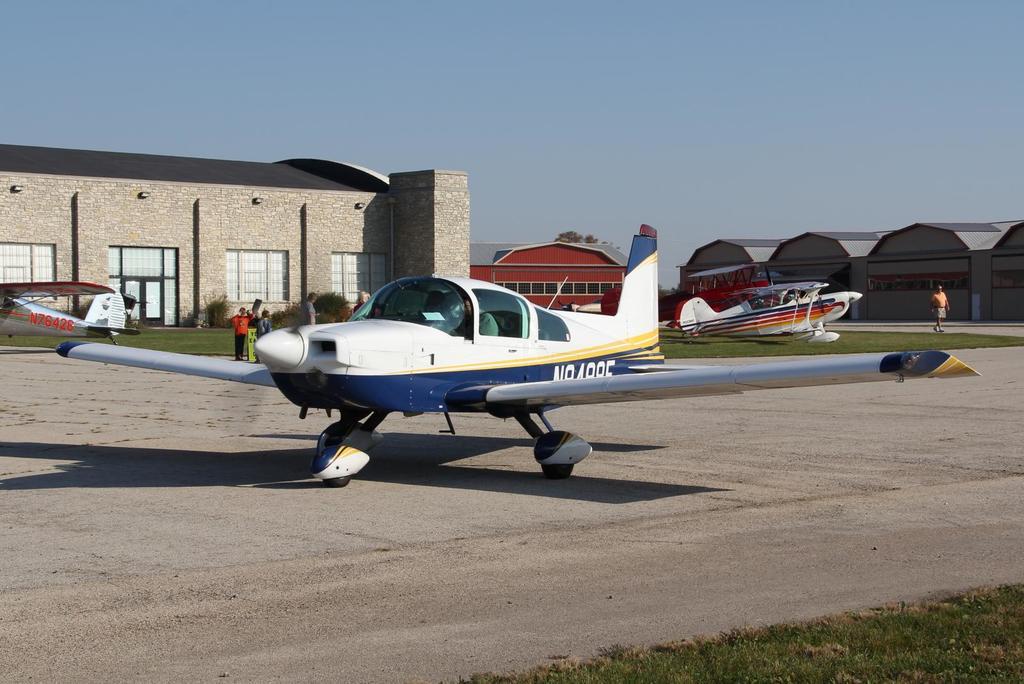Does the plane in front have three tires?
Your response must be concise. Answering does not require reading text in the image. 